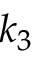Convert formula to latex. <formula><loc_0><loc_0><loc_500><loc_500>k _ { 3 }</formula> 